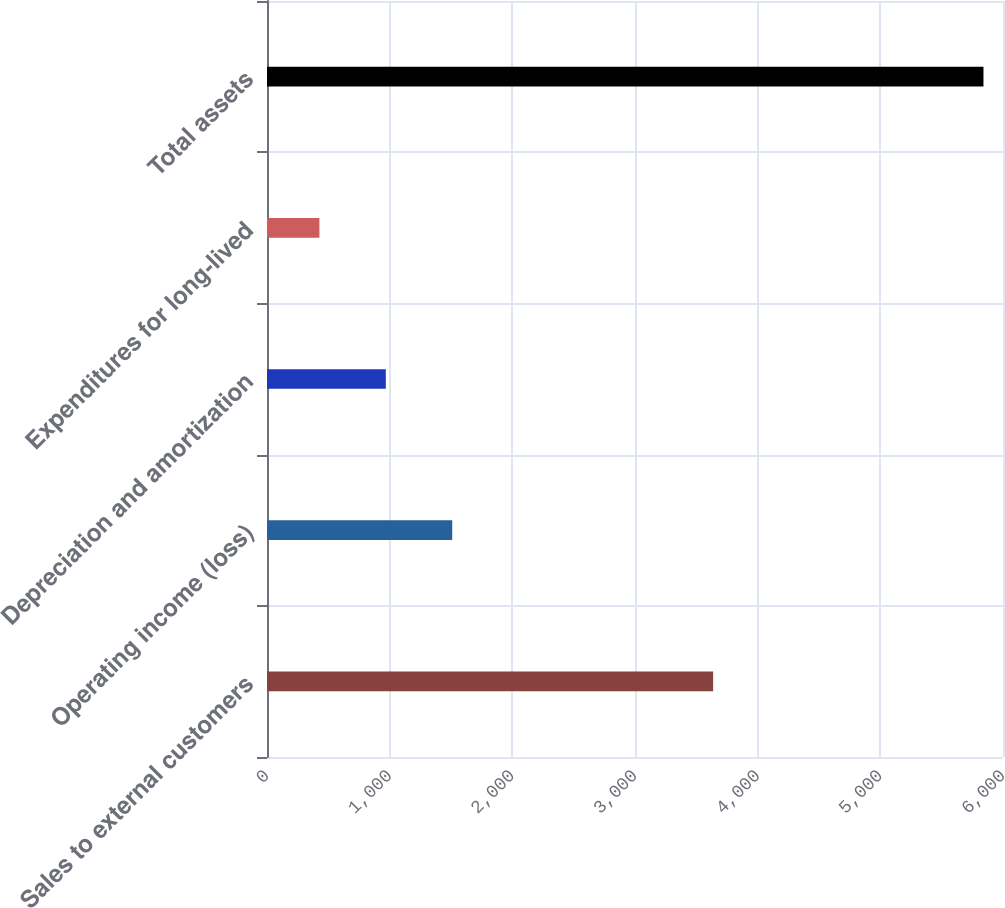<chart> <loc_0><loc_0><loc_500><loc_500><bar_chart><fcel>Sales to external customers<fcel>Operating income (loss)<fcel>Depreciation and amortization<fcel>Expenditures for long-lived<fcel>Total assets<nl><fcel>3637<fcel>1509.92<fcel>968.56<fcel>427.2<fcel>5840.8<nl></chart> 